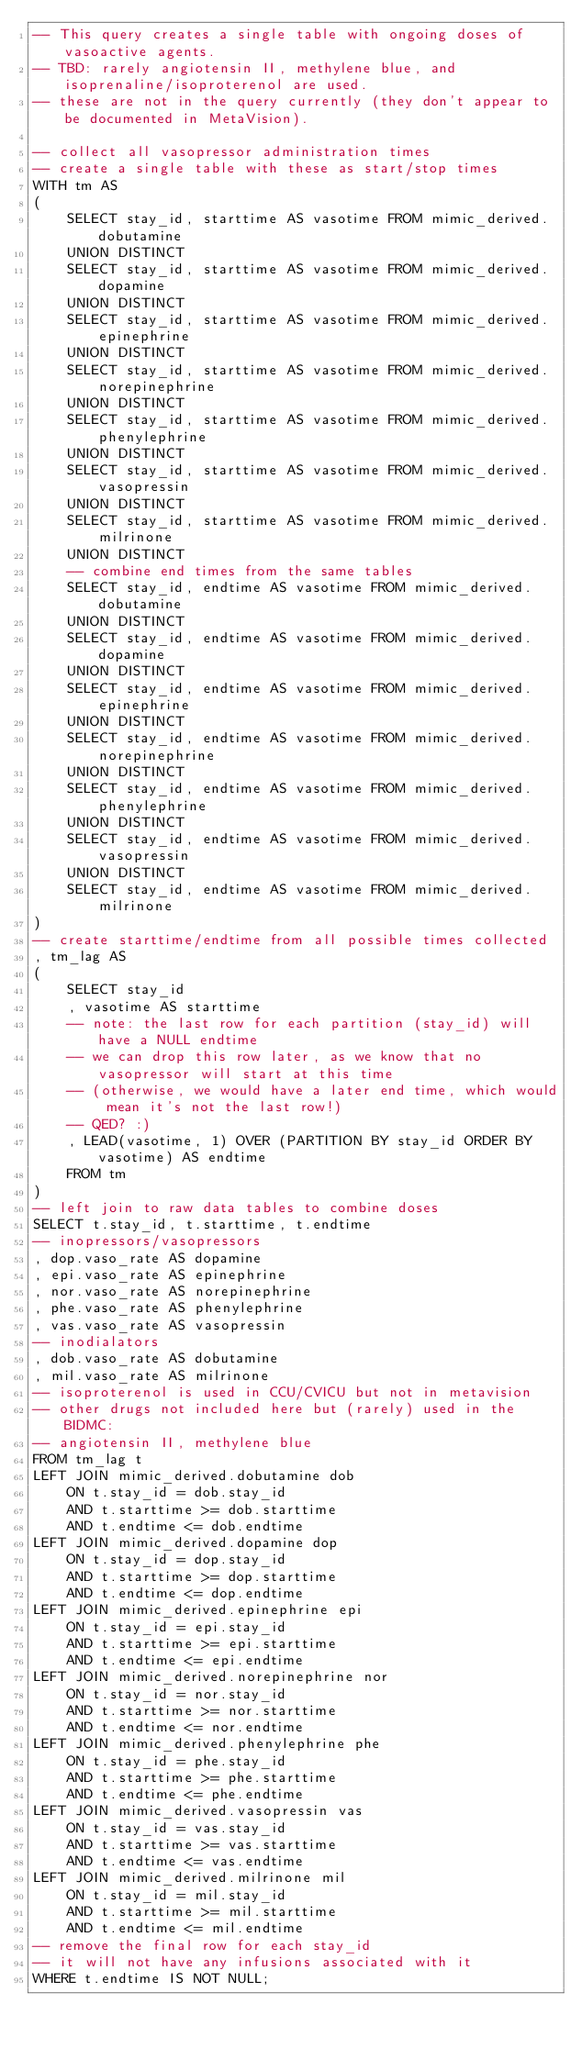<code> <loc_0><loc_0><loc_500><loc_500><_SQL_>-- This query creates a single table with ongoing doses of vasoactive agents.
-- TBD: rarely angiotensin II, methylene blue, and isoprenaline/isoproterenol are used.
-- these are not in the query currently (they don't appear to be documented in MetaVision).

-- collect all vasopressor administration times
-- create a single table with these as start/stop times
WITH tm AS
(
    SELECT stay_id, starttime AS vasotime FROM mimic_derived.dobutamine
    UNION DISTINCT
    SELECT stay_id, starttime AS vasotime FROM mimic_derived.dopamine
    UNION DISTINCT
    SELECT stay_id, starttime AS vasotime FROM mimic_derived.epinephrine
    UNION DISTINCT
    SELECT stay_id, starttime AS vasotime FROM mimic_derived.norepinephrine
    UNION DISTINCT
    SELECT stay_id, starttime AS vasotime FROM mimic_derived.phenylephrine
    UNION DISTINCT
    SELECT stay_id, starttime AS vasotime FROM mimic_derived.vasopressin
    UNION DISTINCT
    SELECT stay_id, starttime AS vasotime FROM mimic_derived.milrinone
    UNION DISTINCT
    -- combine end times from the same tables
    SELECT stay_id, endtime AS vasotime FROM mimic_derived.dobutamine
    UNION DISTINCT
    SELECT stay_id, endtime AS vasotime FROM mimic_derived.dopamine
    UNION DISTINCT
    SELECT stay_id, endtime AS vasotime FROM mimic_derived.epinephrine
    UNION DISTINCT
    SELECT stay_id, endtime AS vasotime FROM mimic_derived.norepinephrine
    UNION DISTINCT
    SELECT stay_id, endtime AS vasotime FROM mimic_derived.phenylephrine
    UNION DISTINCT
    SELECT stay_id, endtime AS vasotime FROM mimic_derived.vasopressin
    UNION DISTINCT
    SELECT stay_id, endtime AS vasotime FROM mimic_derived.milrinone
)
-- create starttime/endtime from all possible times collected
, tm_lag AS
(
    SELECT stay_id
    , vasotime AS starttime
    -- note: the last row for each partition (stay_id) will have a NULL endtime
    -- we can drop this row later, as we know that no vasopressor will start at this time
    -- (otherwise, we would have a later end time, which would mean it's not the last row!)
    -- QED? :)
    , LEAD(vasotime, 1) OVER (PARTITION BY stay_id ORDER BY vasotime) AS endtime
    FROM tm
)
-- left join to raw data tables to combine doses
SELECT t.stay_id, t.starttime, t.endtime
-- inopressors/vasopressors
, dop.vaso_rate AS dopamine
, epi.vaso_rate AS epinephrine
, nor.vaso_rate AS norepinephrine
, phe.vaso_rate AS phenylephrine
, vas.vaso_rate AS vasopressin
-- inodialators
, dob.vaso_rate AS dobutamine
, mil.vaso_rate AS milrinone
-- isoproterenol is used in CCU/CVICU but not in metavision
-- other drugs not included here but (rarely) used in the BIDMC:
-- angiotensin II, methylene blue
FROM tm_lag t
LEFT JOIN mimic_derived.dobutamine dob
    ON t.stay_id = dob.stay_id
    AND t.starttime >= dob.starttime
    AND t.endtime <= dob.endtime
LEFT JOIN mimic_derived.dopamine dop
    ON t.stay_id = dop.stay_id
    AND t.starttime >= dop.starttime
    AND t.endtime <= dop.endtime
LEFT JOIN mimic_derived.epinephrine epi
    ON t.stay_id = epi.stay_id
    AND t.starttime >= epi.starttime
    AND t.endtime <= epi.endtime
LEFT JOIN mimic_derived.norepinephrine nor
    ON t.stay_id = nor.stay_id
    AND t.starttime >= nor.starttime
    AND t.endtime <= nor.endtime
LEFT JOIN mimic_derived.phenylephrine phe
    ON t.stay_id = phe.stay_id
    AND t.starttime >= phe.starttime
    AND t.endtime <= phe.endtime
LEFT JOIN mimic_derived.vasopressin vas
    ON t.stay_id = vas.stay_id
    AND t.starttime >= vas.starttime
    AND t.endtime <= vas.endtime
LEFT JOIN mimic_derived.milrinone mil
    ON t.stay_id = mil.stay_id
    AND t.starttime >= mil.starttime
    AND t.endtime <= mil.endtime
-- remove the final row for each stay_id
-- it will not have any infusions associated with it
WHERE t.endtime IS NOT NULL;</code> 